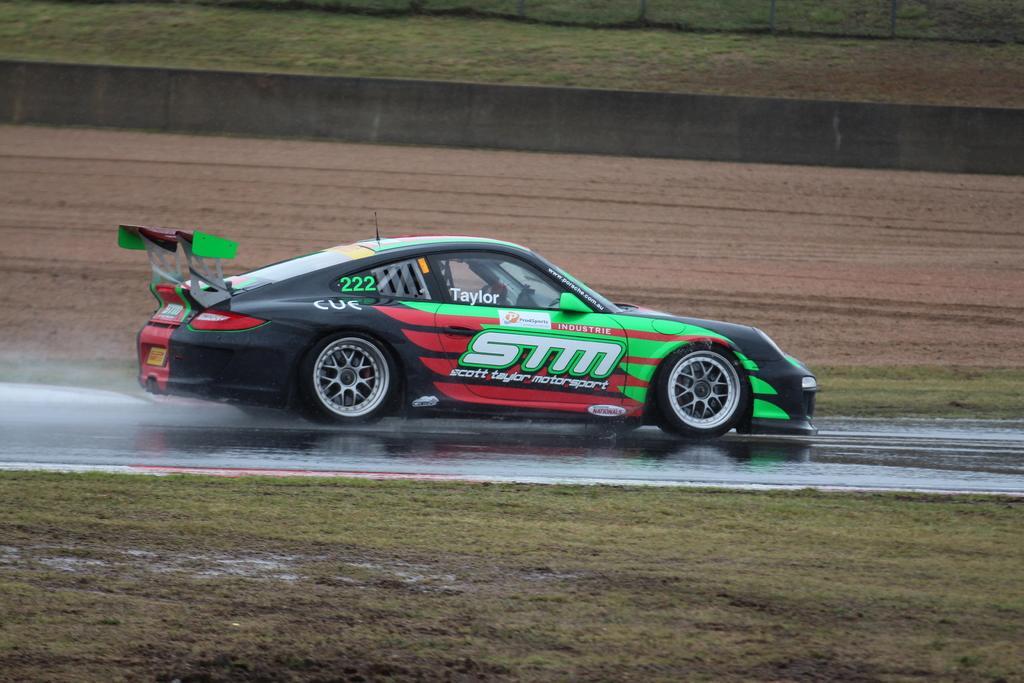How would you summarize this image in a sentence or two? In this picture I can observe a car on the road. The car is in black, green and red colors. In the background I can observe a wall and an open land. 